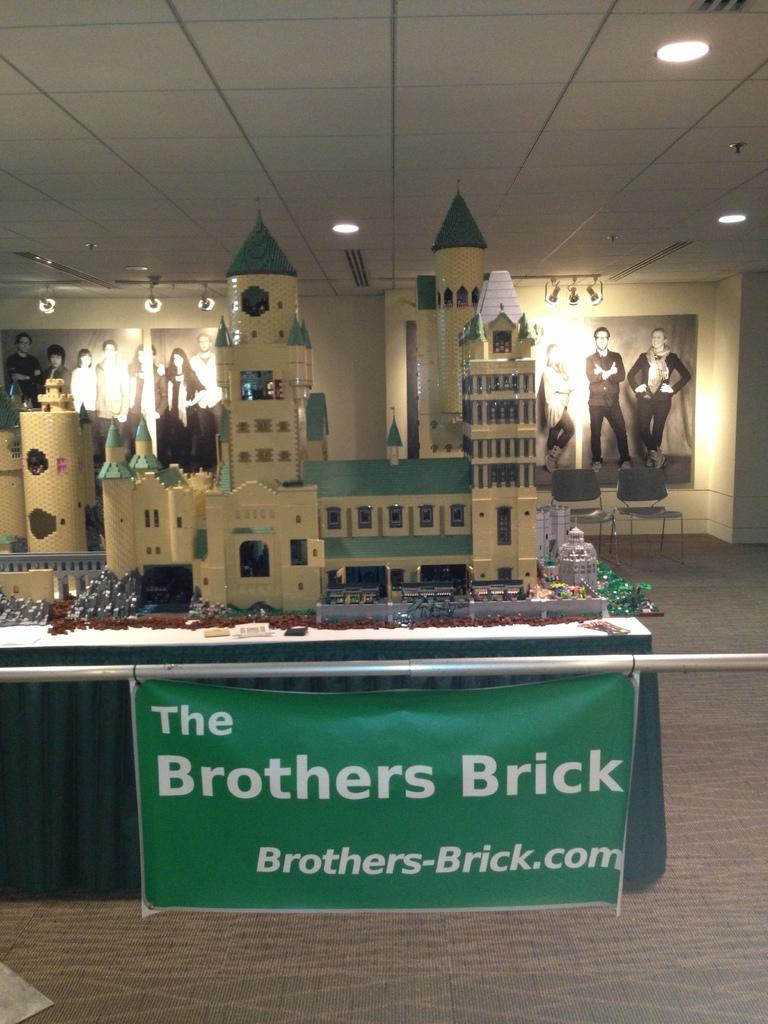<image>
Offer a succinct explanation of the picture presented. A booth by The Brothers Brick houses a large castle made of lego. 